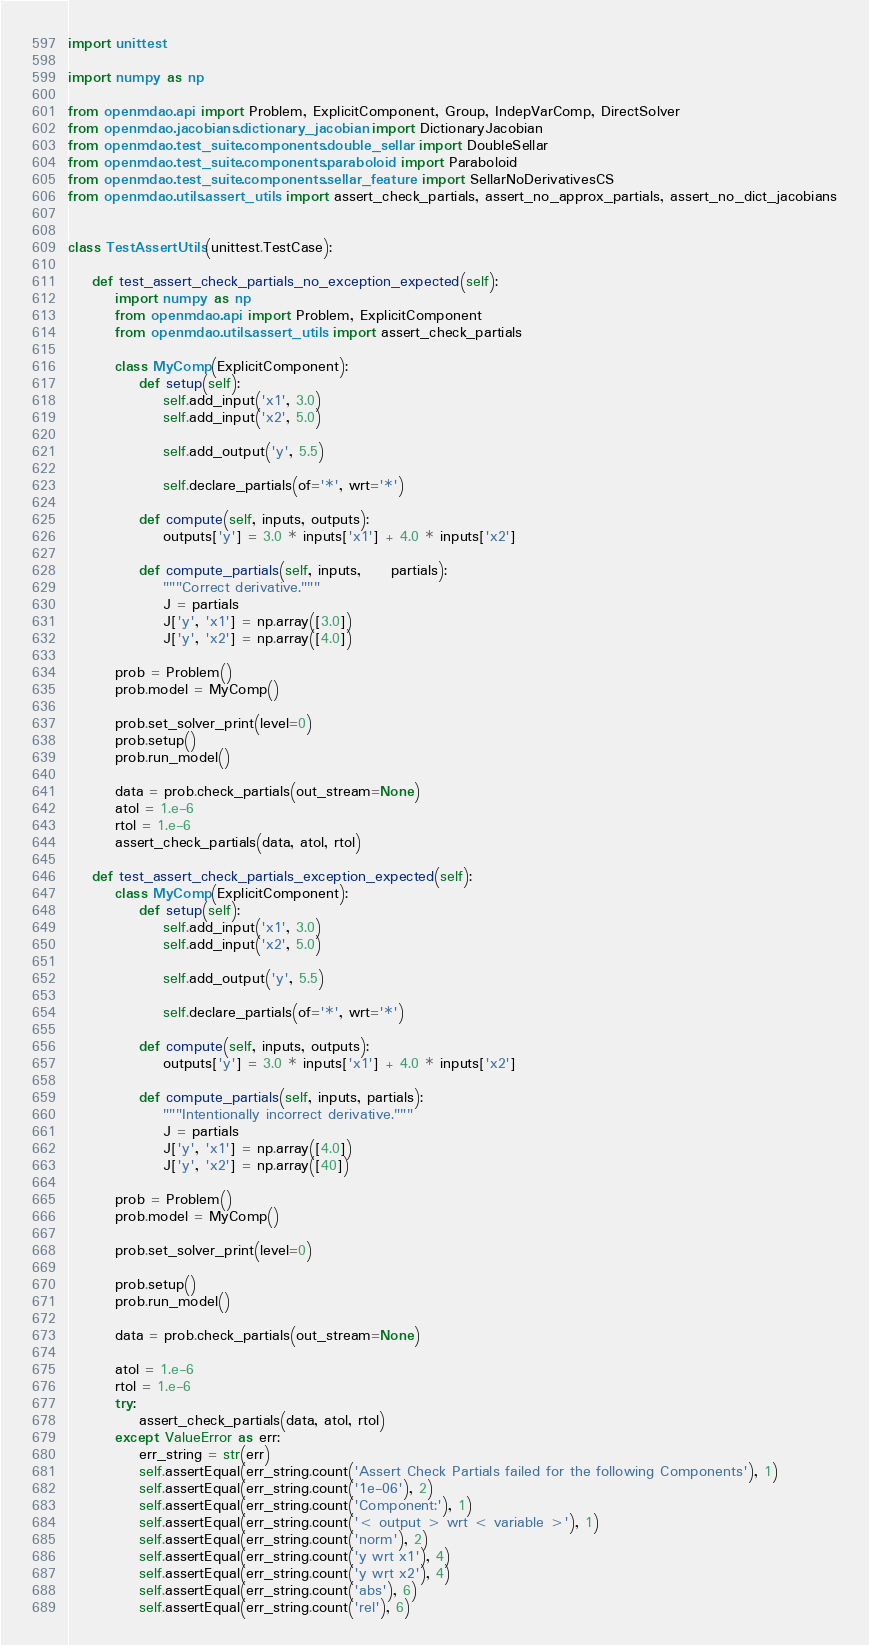Convert code to text. <code><loc_0><loc_0><loc_500><loc_500><_Python_>import unittest

import numpy as np

from openmdao.api import Problem, ExplicitComponent, Group, IndepVarComp, DirectSolver
from openmdao.jacobians.dictionary_jacobian import DictionaryJacobian
from openmdao.test_suite.components.double_sellar import DoubleSellar
from openmdao.test_suite.components.paraboloid import Paraboloid
from openmdao.test_suite.components.sellar_feature import SellarNoDerivativesCS
from openmdao.utils.assert_utils import assert_check_partials, assert_no_approx_partials, assert_no_dict_jacobians


class TestAssertUtils(unittest.TestCase):

    def test_assert_check_partials_no_exception_expected(self):
        import numpy as np
        from openmdao.api import Problem, ExplicitComponent
        from openmdao.utils.assert_utils import assert_check_partials

        class MyComp(ExplicitComponent):
            def setup(self):
                self.add_input('x1', 3.0)
                self.add_input('x2', 5.0)

                self.add_output('y', 5.5)

                self.declare_partials(of='*', wrt='*')

            def compute(self, inputs, outputs):
                outputs['y'] = 3.0 * inputs['x1'] + 4.0 * inputs['x2']

            def compute_partials(self, inputs,     partials):
                """Correct derivative."""
                J = partials
                J['y', 'x1'] = np.array([3.0])
                J['y', 'x2'] = np.array([4.0])

        prob = Problem()
        prob.model = MyComp()

        prob.set_solver_print(level=0)
        prob.setup()
        prob.run_model()

        data = prob.check_partials(out_stream=None)
        atol = 1.e-6
        rtol = 1.e-6
        assert_check_partials(data, atol, rtol)

    def test_assert_check_partials_exception_expected(self):
        class MyComp(ExplicitComponent):
            def setup(self):
                self.add_input('x1', 3.0)
                self.add_input('x2', 5.0)

                self.add_output('y', 5.5)

                self.declare_partials(of='*', wrt='*')

            def compute(self, inputs, outputs):
                outputs['y'] = 3.0 * inputs['x1'] + 4.0 * inputs['x2']

            def compute_partials(self, inputs, partials):
                """Intentionally incorrect derivative."""
                J = partials
                J['y', 'x1'] = np.array([4.0])
                J['y', 'x2'] = np.array([40])

        prob = Problem()
        prob.model = MyComp()

        prob.set_solver_print(level=0)

        prob.setup()
        prob.run_model()

        data = prob.check_partials(out_stream=None)

        atol = 1.e-6
        rtol = 1.e-6
        try:
            assert_check_partials(data, atol, rtol)
        except ValueError as err:
            err_string = str(err)
            self.assertEqual(err_string.count('Assert Check Partials failed for the following Components'), 1)
            self.assertEqual(err_string.count('1e-06'), 2)
            self.assertEqual(err_string.count('Component:'), 1)
            self.assertEqual(err_string.count('< output > wrt < variable >'), 1)
            self.assertEqual(err_string.count('norm'), 2)
            self.assertEqual(err_string.count('y wrt x1'), 4)
            self.assertEqual(err_string.count('y wrt x2'), 4)
            self.assertEqual(err_string.count('abs'), 6)
            self.assertEqual(err_string.count('rel'), 6)</code> 